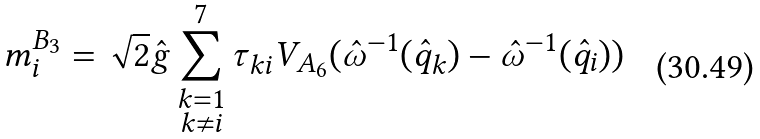<formula> <loc_0><loc_0><loc_500><loc_500>m _ { i } ^ { B _ { 3 } } = \sqrt { 2 } \hat { g } \sum _ { \substack { k = 1 \\ k \neq i } } ^ { 7 } \tau _ { k i } V _ { A _ { 6 } } ( \hat { \omega } ^ { - 1 } ( \hat { q } _ { k } ) - \hat { \omega } ^ { - 1 } ( \hat { q } _ { i } ) )</formula> 